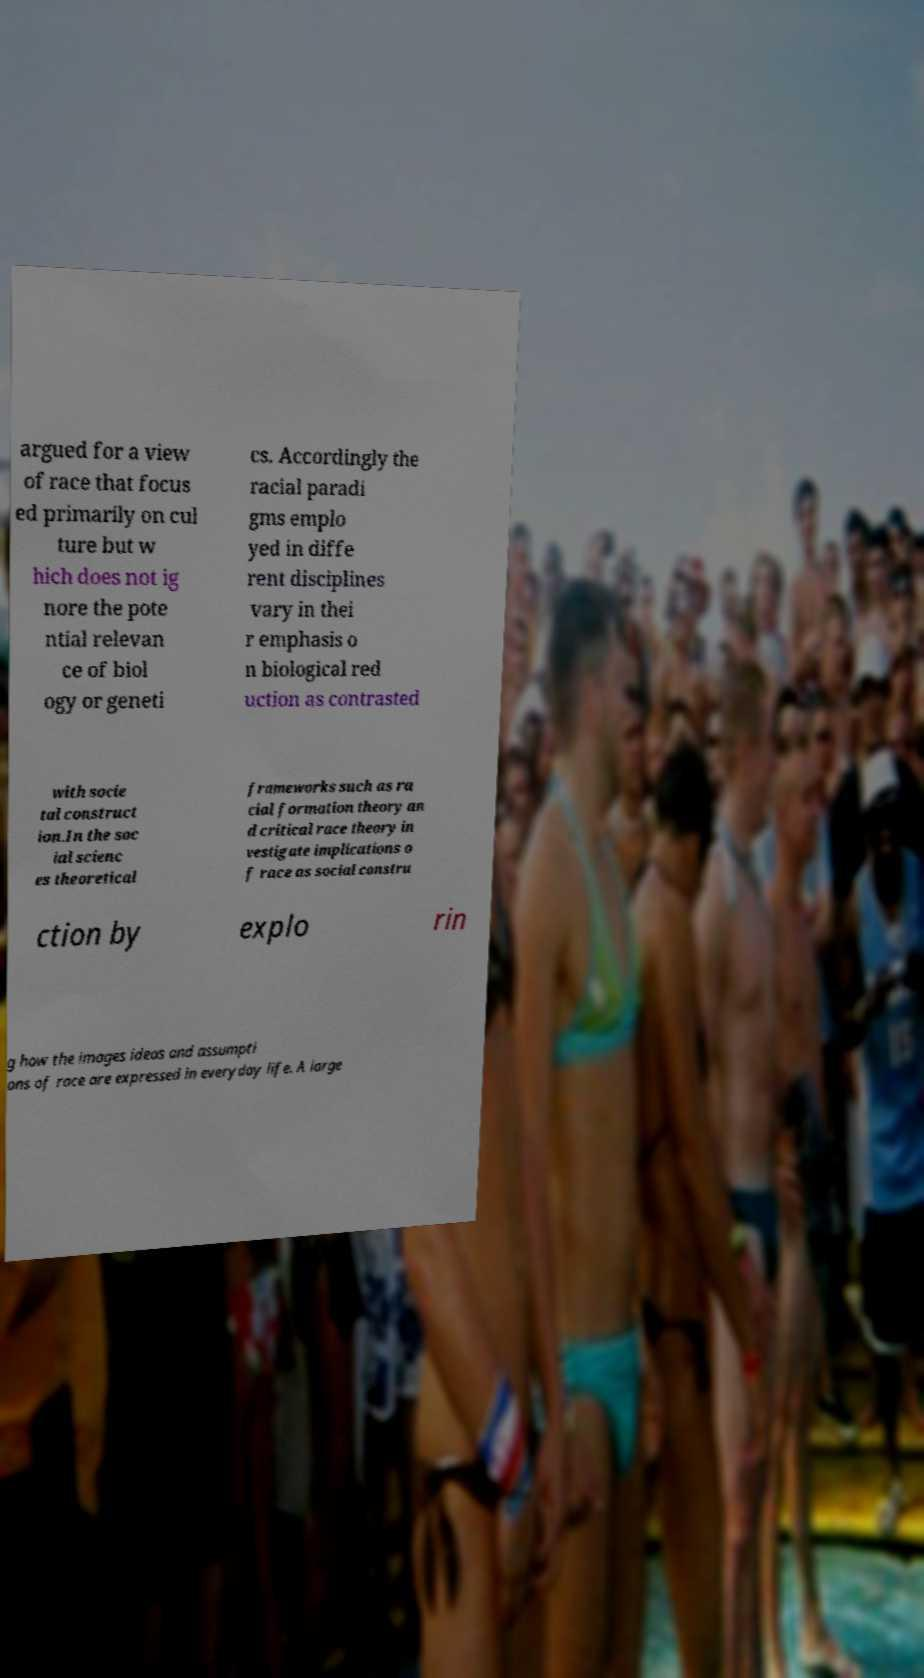Can you read and provide the text displayed in the image?This photo seems to have some interesting text. Can you extract and type it out for me? argued for a view of race that focus ed primarily on cul ture but w hich does not ig nore the pote ntial relevan ce of biol ogy or geneti cs. Accordingly the racial paradi gms emplo yed in diffe rent disciplines vary in thei r emphasis o n biological red uction as contrasted with socie tal construct ion.In the soc ial scienc es theoretical frameworks such as ra cial formation theory an d critical race theory in vestigate implications o f race as social constru ction by explo rin g how the images ideas and assumpti ons of race are expressed in everyday life. A large 